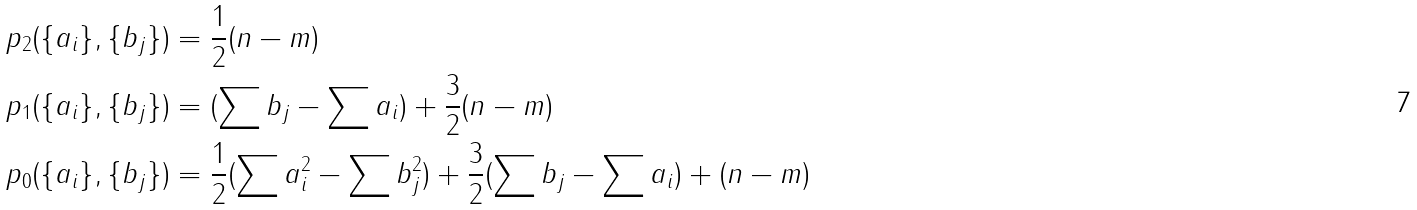<formula> <loc_0><loc_0><loc_500><loc_500>p _ { 2 } ( \{ a _ { i } \} , \{ b _ { j } \} ) & = \frac { 1 } { 2 } ( n - m ) \\ p _ { 1 } ( \{ a _ { i } \} , \{ b _ { j } \} ) & = ( \sum b _ { j } - \sum a _ { i } ) + \frac { 3 } { 2 } ( n - m ) \\ p _ { 0 } ( \{ a _ { i } \} , \{ b _ { j } \} ) & = \frac { 1 } { 2 } ( \sum a _ { i } ^ { 2 } - \sum b _ { j } ^ { 2 } ) + \frac { 3 } { 2 } ( \sum b _ { j } - \sum a _ { i } ) + ( n - m )</formula> 